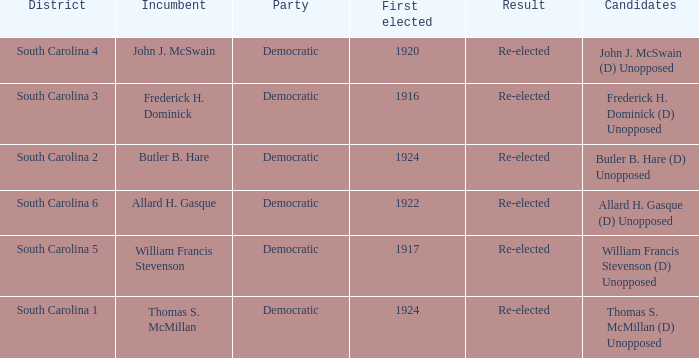What is the party for south carolina 3? Democratic. 